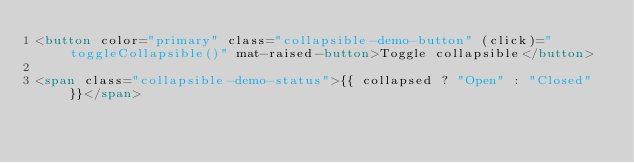Convert code to text. <code><loc_0><loc_0><loc_500><loc_500><_HTML_><button color="primary" class="collapsible-demo-button" (click)="toggleCollapsible()" mat-raised-button>Toggle collapsible</button>

<span class="collapsible-demo-status">{{ collapsed ? "Open" : "Closed" }}</span>
</code> 